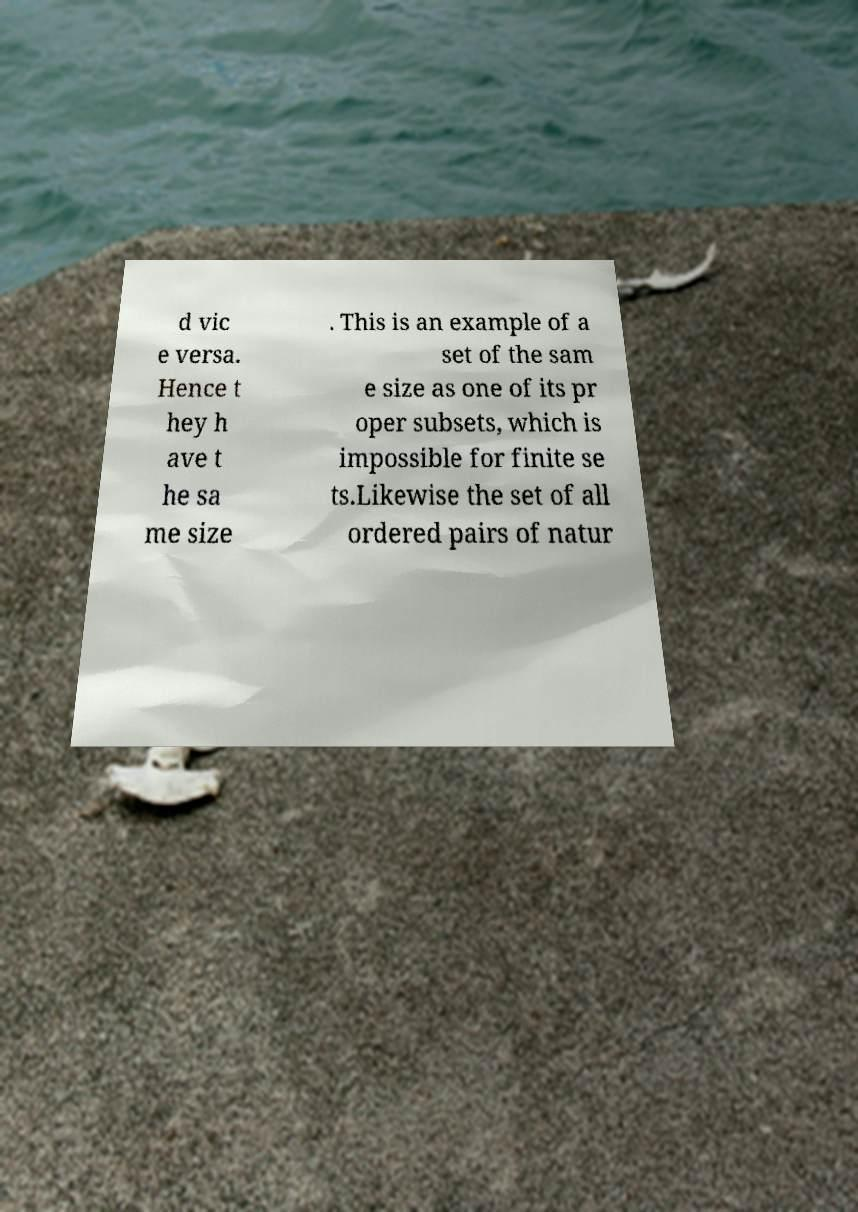For documentation purposes, I need the text within this image transcribed. Could you provide that? d vic e versa. Hence t hey h ave t he sa me size . This is an example of a set of the sam e size as one of its pr oper subsets, which is impossible for finite se ts.Likewise the set of all ordered pairs of natur 